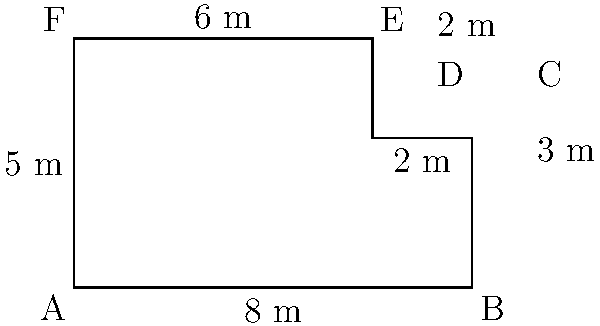Your café has an irregularly shaped floor plan as shown in the diagram. Calculate the perimeter of the café floor in meters. To calculate the perimeter of the café floor, we need to sum up the lengths of all sides:

1. Side AB: 8 m
2. Side BC: 3 m
3. Side CD: 2 m
4. Side DE: 2 m
5. Side EF: 6 m
6. Side FA: 5 m

Adding all these lengths:

$$\text{Perimeter} = 8 + 3 + 2 + 2 + 6 + 5 = 26\text{ m}$$

Therefore, the perimeter of the café floor is 26 meters.
Answer: 26 m 